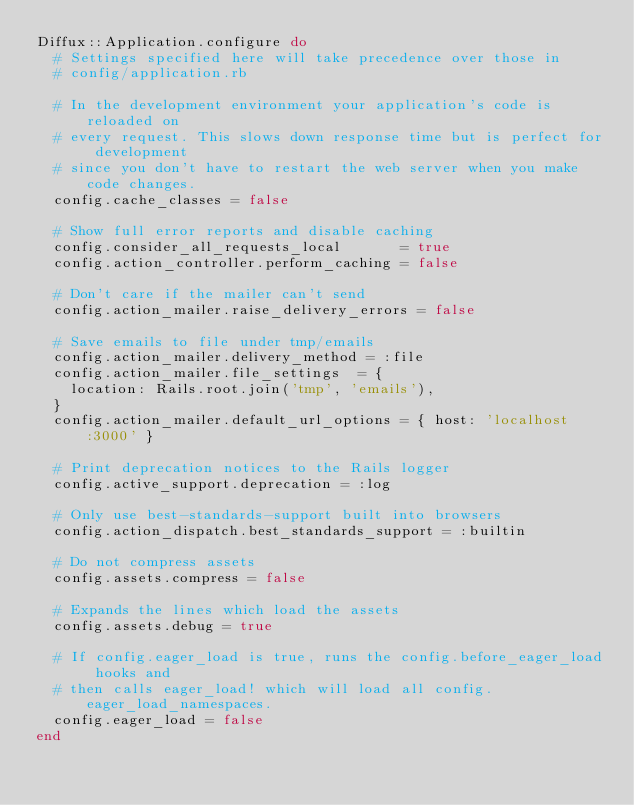<code> <loc_0><loc_0><loc_500><loc_500><_Ruby_>Diffux::Application.configure do
  # Settings specified here will take precedence over those in
  # config/application.rb

  # In the development environment your application's code is reloaded on
  # every request. This slows down response time but is perfect for development
  # since you don't have to restart the web server when you make code changes.
  config.cache_classes = false

  # Show full error reports and disable caching
  config.consider_all_requests_local       = true
  config.action_controller.perform_caching = false

  # Don't care if the mailer can't send
  config.action_mailer.raise_delivery_errors = false

  # Save emails to file under tmp/emails
  config.action_mailer.delivery_method = :file
  config.action_mailer.file_settings  = {
    location: Rails.root.join('tmp', 'emails'),
  }
  config.action_mailer.default_url_options = { host: 'localhost:3000' }

  # Print deprecation notices to the Rails logger
  config.active_support.deprecation = :log

  # Only use best-standards-support built into browsers
  config.action_dispatch.best_standards_support = :builtin

  # Do not compress assets
  config.assets.compress = false

  # Expands the lines which load the assets
  config.assets.debug = true

  # If config.eager_load is true, runs the config.before_eager_load hooks and
  # then calls eager_load! which will load all config.eager_load_namespaces.
  config.eager_load = false
end
</code> 